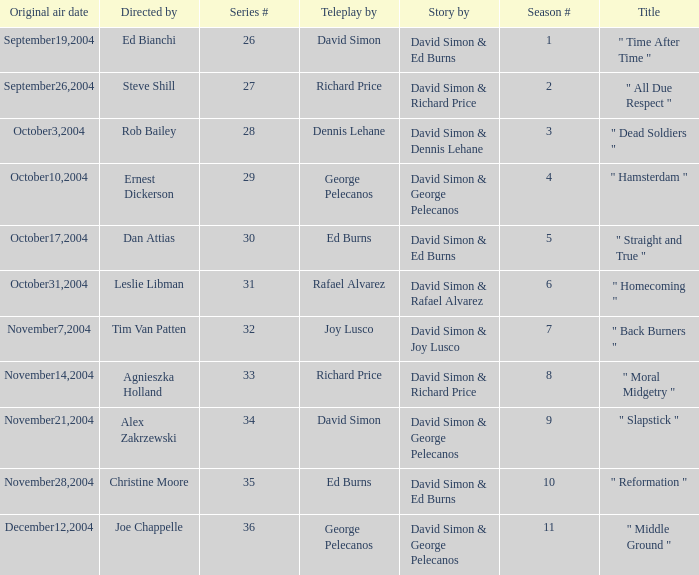What is the season # for a teleplay by Richard Price and the director is Steve Shill? 2.0. 